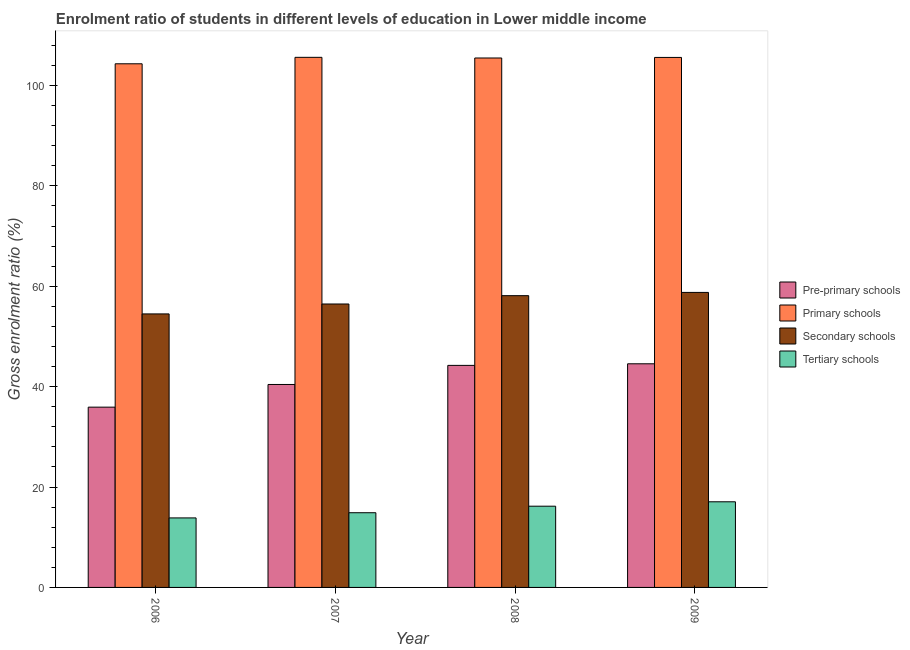How many bars are there on the 1st tick from the right?
Your response must be concise. 4. In how many cases, is the number of bars for a given year not equal to the number of legend labels?
Offer a terse response. 0. What is the gross enrolment ratio in pre-primary schools in 2007?
Your answer should be very brief. 40.44. Across all years, what is the maximum gross enrolment ratio in tertiary schools?
Your answer should be compact. 17.06. Across all years, what is the minimum gross enrolment ratio in secondary schools?
Your response must be concise. 54.5. What is the total gross enrolment ratio in tertiary schools in the graph?
Offer a terse response. 61.98. What is the difference between the gross enrolment ratio in tertiary schools in 2006 and that in 2009?
Your answer should be very brief. -3.21. What is the difference between the gross enrolment ratio in tertiary schools in 2008 and the gross enrolment ratio in primary schools in 2009?
Offer a very short reply. -0.88. What is the average gross enrolment ratio in pre-primary schools per year?
Keep it short and to the point. 41.29. In how many years, is the gross enrolment ratio in secondary schools greater than 64 %?
Your answer should be very brief. 0. What is the ratio of the gross enrolment ratio in primary schools in 2007 to that in 2008?
Offer a very short reply. 1. Is the gross enrolment ratio in secondary schools in 2007 less than that in 2008?
Offer a very short reply. Yes. What is the difference between the highest and the second highest gross enrolment ratio in primary schools?
Ensure brevity in your answer.  0.02. What is the difference between the highest and the lowest gross enrolment ratio in secondary schools?
Offer a terse response. 4.28. In how many years, is the gross enrolment ratio in secondary schools greater than the average gross enrolment ratio in secondary schools taken over all years?
Make the answer very short. 2. Is the sum of the gross enrolment ratio in pre-primary schools in 2007 and 2008 greater than the maximum gross enrolment ratio in tertiary schools across all years?
Offer a very short reply. Yes. Is it the case that in every year, the sum of the gross enrolment ratio in tertiary schools and gross enrolment ratio in secondary schools is greater than the sum of gross enrolment ratio in pre-primary schools and gross enrolment ratio in primary schools?
Your answer should be very brief. No. What does the 4th bar from the left in 2009 represents?
Provide a succinct answer. Tertiary schools. What does the 3rd bar from the right in 2008 represents?
Provide a short and direct response. Primary schools. Is it the case that in every year, the sum of the gross enrolment ratio in pre-primary schools and gross enrolment ratio in primary schools is greater than the gross enrolment ratio in secondary schools?
Make the answer very short. Yes. How many bars are there?
Ensure brevity in your answer.  16. What is the difference between two consecutive major ticks on the Y-axis?
Make the answer very short. 20. Does the graph contain any zero values?
Give a very brief answer. No. Does the graph contain grids?
Make the answer very short. No. Where does the legend appear in the graph?
Your response must be concise. Center right. How are the legend labels stacked?
Offer a very short reply. Vertical. What is the title of the graph?
Your response must be concise. Enrolment ratio of students in different levels of education in Lower middle income. Does "Subsidies and Transfers" appear as one of the legend labels in the graph?
Ensure brevity in your answer.  No. What is the label or title of the X-axis?
Give a very brief answer. Year. What is the Gross enrolment ratio (%) in Pre-primary schools in 2006?
Your answer should be compact. 35.92. What is the Gross enrolment ratio (%) of Primary schools in 2006?
Your answer should be compact. 104.33. What is the Gross enrolment ratio (%) in Secondary schools in 2006?
Your response must be concise. 54.5. What is the Gross enrolment ratio (%) in Tertiary schools in 2006?
Give a very brief answer. 13.85. What is the Gross enrolment ratio (%) of Pre-primary schools in 2007?
Provide a short and direct response. 40.44. What is the Gross enrolment ratio (%) of Primary schools in 2007?
Your answer should be compact. 105.62. What is the Gross enrolment ratio (%) in Secondary schools in 2007?
Provide a short and direct response. 56.47. What is the Gross enrolment ratio (%) in Tertiary schools in 2007?
Your answer should be compact. 14.88. What is the Gross enrolment ratio (%) of Pre-primary schools in 2008?
Offer a very short reply. 44.24. What is the Gross enrolment ratio (%) of Primary schools in 2008?
Keep it short and to the point. 105.49. What is the Gross enrolment ratio (%) of Secondary schools in 2008?
Make the answer very short. 58.13. What is the Gross enrolment ratio (%) of Tertiary schools in 2008?
Ensure brevity in your answer.  16.18. What is the Gross enrolment ratio (%) in Pre-primary schools in 2009?
Offer a terse response. 44.56. What is the Gross enrolment ratio (%) in Primary schools in 2009?
Offer a very short reply. 105.6. What is the Gross enrolment ratio (%) in Secondary schools in 2009?
Offer a terse response. 58.78. What is the Gross enrolment ratio (%) in Tertiary schools in 2009?
Offer a very short reply. 17.06. Across all years, what is the maximum Gross enrolment ratio (%) of Pre-primary schools?
Give a very brief answer. 44.56. Across all years, what is the maximum Gross enrolment ratio (%) in Primary schools?
Keep it short and to the point. 105.62. Across all years, what is the maximum Gross enrolment ratio (%) of Secondary schools?
Your answer should be compact. 58.78. Across all years, what is the maximum Gross enrolment ratio (%) of Tertiary schools?
Provide a succinct answer. 17.06. Across all years, what is the minimum Gross enrolment ratio (%) in Pre-primary schools?
Your response must be concise. 35.92. Across all years, what is the minimum Gross enrolment ratio (%) of Primary schools?
Your response must be concise. 104.33. Across all years, what is the minimum Gross enrolment ratio (%) of Secondary schools?
Give a very brief answer. 54.5. Across all years, what is the minimum Gross enrolment ratio (%) in Tertiary schools?
Keep it short and to the point. 13.85. What is the total Gross enrolment ratio (%) of Pre-primary schools in the graph?
Give a very brief answer. 165.16. What is the total Gross enrolment ratio (%) of Primary schools in the graph?
Your answer should be compact. 421.04. What is the total Gross enrolment ratio (%) in Secondary schools in the graph?
Provide a short and direct response. 227.88. What is the total Gross enrolment ratio (%) in Tertiary schools in the graph?
Your answer should be compact. 61.98. What is the difference between the Gross enrolment ratio (%) of Pre-primary schools in 2006 and that in 2007?
Offer a very short reply. -4.51. What is the difference between the Gross enrolment ratio (%) of Primary schools in 2006 and that in 2007?
Your response must be concise. -1.29. What is the difference between the Gross enrolment ratio (%) of Secondary schools in 2006 and that in 2007?
Offer a terse response. -1.98. What is the difference between the Gross enrolment ratio (%) of Tertiary schools in 2006 and that in 2007?
Offer a very short reply. -1.03. What is the difference between the Gross enrolment ratio (%) of Pre-primary schools in 2006 and that in 2008?
Provide a short and direct response. -8.32. What is the difference between the Gross enrolment ratio (%) of Primary schools in 2006 and that in 2008?
Provide a succinct answer. -1.15. What is the difference between the Gross enrolment ratio (%) in Secondary schools in 2006 and that in 2008?
Your answer should be compact. -3.63. What is the difference between the Gross enrolment ratio (%) in Tertiary schools in 2006 and that in 2008?
Offer a very short reply. -2.33. What is the difference between the Gross enrolment ratio (%) of Pre-primary schools in 2006 and that in 2009?
Your answer should be very brief. -8.64. What is the difference between the Gross enrolment ratio (%) of Primary schools in 2006 and that in 2009?
Your response must be concise. -1.27. What is the difference between the Gross enrolment ratio (%) of Secondary schools in 2006 and that in 2009?
Offer a very short reply. -4.28. What is the difference between the Gross enrolment ratio (%) of Tertiary schools in 2006 and that in 2009?
Your response must be concise. -3.21. What is the difference between the Gross enrolment ratio (%) in Pre-primary schools in 2007 and that in 2008?
Provide a short and direct response. -3.8. What is the difference between the Gross enrolment ratio (%) in Primary schools in 2007 and that in 2008?
Provide a succinct answer. 0.13. What is the difference between the Gross enrolment ratio (%) in Secondary schools in 2007 and that in 2008?
Provide a short and direct response. -1.66. What is the difference between the Gross enrolment ratio (%) in Tertiary schools in 2007 and that in 2008?
Keep it short and to the point. -1.3. What is the difference between the Gross enrolment ratio (%) of Pre-primary schools in 2007 and that in 2009?
Your answer should be very brief. -4.12. What is the difference between the Gross enrolment ratio (%) of Primary schools in 2007 and that in 2009?
Offer a terse response. 0.02. What is the difference between the Gross enrolment ratio (%) of Secondary schools in 2007 and that in 2009?
Ensure brevity in your answer.  -2.31. What is the difference between the Gross enrolment ratio (%) of Tertiary schools in 2007 and that in 2009?
Make the answer very short. -2.18. What is the difference between the Gross enrolment ratio (%) in Pre-primary schools in 2008 and that in 2009?
Provide a succinct answer. -0.32. What is the difference between the Gross enrolment ratio (%) in Primary schools in 2008 and that in 2009?
Your response must be concise. -0.11. What is the difference between the Gross enrolment ratio (%) of Secondary schools in 2008 and that in 2009?
Keep it short and to the point. -0.65. What is the difference between the Gross enrolment ratio (%) of Tertiary schools in 2008 and that in 2009?
Your answer should be compact. -0.88. What is the difference between the Gross enrolment ratio (%) in Pre-primary schools in 2006 and the Gross enrolment ratio (%) in Primary schools in 2007?
Keep it short and to the point. -69.7. What is the difference between the Gross enrolment ratio (%) in Pre-primary schools in 2006 and the Gross enrolment ratio (%) in Secondary schools in 2007?
Make the answer very short. -20.55. What is the difference between the Gross enrolment ratio (%) in Pre-primary schools in 2006 and the Gross enrolment ratio (%) in Tertiary schools in 2007?
Make the answer very short. 21.04. What is the difference between the Gross enrolment ratio (%) in Primary schools in 2006 and the Gross enrolment ratio (%) in Secondary schools in 2007?
Provide a short and direct response. 47.86. What is the difference between the Gross enrolment ratio (%) of Primary schools in 2006 and the Gross enrolment ratio (%) of Tertiary schools in 2007?
Offer a terse response. 89.45. What is the difference between the Gross enrolment ratio (%) of Secondary schools in 2006 and the Gross enrolment ratio (%) of Tertiary schools in 2007?
Give a very brief answer. 39.62. What is the difference between the Gross enrolment ratio (%) in Pre-primary schools in 2006 and the Gross enrolment ratio (%) in Primary schools in 2008?
Offer a terse response. -69.57. What is the difference between the Gross enrolment ratio (%) in Pre-primary schools in 2006 and the Gross enrolment ratio (%) in Secondary schools in 2008?
Provide a short and direct response. -22.21. What is the difference between the Gross enrolment ratio (%) in Pre-primary schools in 2006 and the Gross enrolment ratio (%) in Tertiary schools in 2008?
Keep it short and to the point. 19.74. What is the difference between the Gross enrolment ratio (%) in Primary schools in 2006 and the Gross enrolment ratio (%) in Secondary schools in 2008?
Give a very brief answer. 46.2. What is the difference between the Gross enrolment ratio (%) in Primary schools in 2006 and the Gross enrolment ratio (%) in Tertiary schools in 2008?
Provide a short and direct response. 88.15. What is the difference between the Gross enrolment ratio (%) of Secondary schools in 2006 and the Gross enrolment ratio (%) of Tertiary schools in 2008?
Offer a terse response. 38.31. What is the difference between the Gross enrolment ratio (%) of Pre-primary schools in 2006 and the Gross enrolment ratio (%) of Primary schools in 2009?
Your response must be concise. -69.68. What is the difference between the Gross enrolment ratio (%) of Pre-primary schools in 2006 and the Gross enrolment ratio (%) of Secondary schools in 2009?
Make the answer very short. -22.86. What is the difference between the Gross enrolment ratio (%) in Pre-primary schools in 2006 and the Gross enrolment ratio (%) in Tertiary schools in 2009?
Provide a short and direct response. 18.86. What is the difference between the Gross enrolment ratio (%) in Primary schools in 2006 and the Gross enrolment ratio (%) in Secondary schools in 2009?
Make the answer very short. 45.55. What is the difference between the Gross enrolment ratio (%) of Primary schools in 2006 and the Gross enrolment ratio (%) of Tertiary schools in 2009?
Offer a terse response. 87.27. What is the difference between the Gross enrolment ratio (%) of Secondary schools in 2006 and the Gross enrolment ratio (%) of Tertiary schools in 2009?
Offer a terse response. 37.43. What is the difference between the Gross enrolment ratio (%) in Pre-primary schools in 2007 and the Gross enrolment ratio (%) in Primary schools in 2008?
Your response must be concise. -65.05. What is the difference between the Gross enrolment ratio (%) in Pre-primary schools in 2007 and the Gross enrolment ratio (%) in Secondary schools in 2008?
Provide a succinct answer. -17.7. What is the difference between the Gross enrolment ratio (%) in Pre-primary schools in 2007 and the Gross enrolment ratio (%) in Tertiary schools in 2008?
Offer a terse response. 24.25. What is the difference between the Gross enrolment ratio (%) of Primary schools in 2007 and the Gross enrolment ratio (%) of Secondary schools in 2008?
Ensure brevity in your answer.  47.49. What is the difference between the Gross enrolment ratio (%) in Primary schools in 2007 and the Gross enrolment ratio (%) in Tertiary schools in 2008?
Offer a terse response. 89.44. What is the difference between the Gross enrolment ratio (%) in Secondary schools in 2007 and the Gross enrolment ratio (%) in Tertiary schools in 2008?
Offer a very short reply. 40.29. What is the difference between the Gross enrolment ratio (%) of Pre-primary schools in 2007 and the Gross enrolment ratio (%) of Primary schools in 2009?
Make the answer very short. -65.16. What is the difference between the Gross enrolment ratio (%) in Pre-primary schools in 2007 and the Gross enrolment ratio (%) in Secondary schools in 2009?
Your response must be concise. -18.34. What is the difference between the Gross enrolment ratio (%) of Pre-primary schools in 2007 and the Gross enrolment ratio (%) of Tertiary schools in 2009?
Provide a short and direct response. 23.37. What is the difference between the Gross enrolment ratio (%) of Primary schools in 2007 and the Gross enrolment ratio (%) of Secondary schools in 2009?
Provide a short and direct response. 46.84. What is the difference between the Gross enrolment ratio (%) of Primary schools in 2007 and the Gross enrolment ratio (%) of Tertiary schools in 2009?
Your response must be concise. 88.56. What is the difference between the Gross enrolment ratio (%) of Secondary schools in 2007 and the Gross enrolment ratio (%) of Tertiary schools in 2009?
Your answer should be very brief. 39.41. What is the difference between the Gross enrolment ratio (%) in Pre-primary schools in 2008 and the Gross enrolment ratio (%) in Primary schools in 2009?
Make the answer very short. -61.36. What is the difference between the Gross enrolment ratio (%) of Pre-primary schools in 2008 and the Gross enrolment ratio (%) of Secondary schools in 2009?
Your answer should be very brief. -14.54. What is the difference between the Gross enrolment ratio (%) in Pre-primary schools in 2008 and the Gross enrolment ratio (%) in Tertiary schools in 2009?
Give a very brief answer. 27.18. What is the difference between the Gross enrolment ratio (%) of Primary schools in 2008 and the Gross enrolment ratio (%) of Secondary schools in 2009?
Your answer should be compact. 46.71. What is the difference between the Gross enrolment ratio (%) in Primary schools in 2008 and the Gross enrolment ratio (%) in Tertiary schools in 2009?
Offer a very short reply. 88.42. What is the difference between the Gross enrolment ratio (%) in Secondary schools in 2008 and the Gross enrolment ratio (%) in Tertiary schools in 2009?
Keep it short and to the point. 41.07. What is the average Gross enrolment ratio (%) in Pre-primary schools per year?
Give a very brief answer. 41.29. What is the average Gross enrolment ratio (%) in Primary schools per year?
Offer a terse response. 105.26. What is the average Gross enrolment ratio (%) of Secondary schools per year?
Keep it short and to the point. 56.97. What is the average Gross enrolment ratio (%) of Tertiary schools per year?
Your answer should be compact. 15.49. In the year 2006, what is the difference between the Gross enrolment ratio (%) in Pre-primary schools and Gross enrolment ratio (%) in Primary schools?
Your response must be concise. -68.41. In the year 2006, what is the difference between the Gross enrolment ratio (%) in Pre-primary schools and Gross enrolment ratio (%) in Secondary schools?
Offer a very short reply. -18.58. In the year 2006, what is the difference between the Gross enrolment ratio (%) of Pre-primary schools and Gross enrolment ratio (%) of Tertiary schools?
Offer a very short reply. 22.07. In the year 2006, what is the difference between the Gross enrolment ratio (%) in Primary schools and Gross enrolment ratio (%) in Secondary schools?
Your answer should be compact. 49.83. In the year 2006, what is the difference between the Gross enrolment ratio (%) in Primary schools and Gross enrolment ratio (%) in Tertiary schools?
Your response must be concise. 90.48. In the year 2006, what is the difference between the Gross enrolment ratio (%) in Secondary schools and Gross enrolment ratio (%) in Tertiary schools?
Give a very brief answer. 40.65. In the year 2007, what is the difference between the Gross enrolment ratio (%) in Pre-primary schools and Gross enrolment ratio (%) in Primary schools?
Your response must be concise. -65.18. In the year 2007, what is the difference between the Gross enrolment ratio (%) in Pre-primary schools and Gross enrolment ratio (%) in Secondary schools?
Give a very brief answer. -16.04. In the year 2007, what is the difference between the Gross enrolment ratio (%) in Pre-primary schools and Gross enrolment ratio (%) in Tertiary schools?
Offer a terse response. 25.55. In the year 2007, what is the difference between the Gross enrolment ratio (%) in Primary schools and Gross enrolment ratio (%) in Secondary schools?
Offer a terse response. 49.15. In the year 2007, what is the difference between the Gross enrolment ratio (%) in Primary schools and Gross enrolment ratio (%) in Tertiary schools?
Offer a terse response. 90.74. In the year 2007, what is the difference between the Gross enrolment ratio (%) of Secondary schools and Gross enrolment ratio (%) of Tertiary schools?
Provide a succinct answer. 41.59. In the year 2008, what is the difference between the Gross enrolment ratio (%) in Pre-primary schools and Gross enrolment ratio (%) in Primary schools?
Your response must be concise. -61.25. In the year 2008, what is the difference between the Gross enrolment ratio (%) of Pre-primary schools and Gross enrolment ratio (%) of Secondary schools?
Your response must be concise. -13.89. In the year 2008, what is the difference between the Gross enrolment ratio (%) in Pre-primary schools and Gross enrolment ratio (%) in Tertiary schools?
Offer a very short reply. 28.06. In the year 2008, what is the difference between the Gross enrolment ratio (%) of Primary schools and Gross enrolment ratio (%) of Secondary schools?
Provide a short and direct response. 47.35. In the year 2008, what is the difference between the Gross enrolment ratio (%) in Primary schools and Gross enrolment ratio (%) in Tertiary schools?
Your answer should be compact. 89.3. In the year 2008, what is the difference between the Gross enrolment ratio (%) of Secondary schools and Gross enrolment ratio (%) of Tertiary schools?
Ensure brevity in your answer.  41.95. In the year 2009, what is the difference between the Gross enrolment ratio (%) of Pre-primary schools and Gross enrolment ratio (%) of Primary schools?
Your answer should be very brief. -61.04. In the year 2009, what is the difference between the Gross enrolment ratio (%) of Pre-primary schools and Gross enrolment ratio (%) of Secondary schools?
Provide a succinct answer. -14.22. In the year 2009, what is the difference between the Gross enrolment ratio (%) of Pre-primary schools and Gross enrolment ratio (%) of Tertiary schools?
Your response must be concise. 27.5. In the year 2009, what is the difference between the Gross enrolment ratio (%) of Primary schools and Gross enrolment ratio (%) of Secondary schools?
Your answer should be very brief. 46.82. In the year 2009, what is the difference between the Gross enrolment ratio (%) in Primary schools and Gross enrolment ratio (%) in Tertiary schools?
Offer a terse response. 88.54. In the year 2009, what is the difference between the Gross enrolment ratio (%) in Secondary schools and Gross enrolment ratio (%) in Tertiary schools?
Provide a succinct answer. 41.72. What is the ratio of the Gross enrolment ratio (%) in Pre-primary schools in 2006 to that in 2007?
Keep it short and to the point. 0.89. What is the ratio of the Gross enrolment ratio (%) in Tertiary schools in 2006 to that in 2007?
Provide a short and direct response. 0.93. What is the ratio of the Gross enrolment ratio (%) of Pre-primary schools in 2006 to that in 2008?
Offer a very short reply. 0.81. What is the ratio of the Gross enrolment ratio (%) in Primary schools in 2006 to that in 2008?
Provide a succinct answer. 0.99. What is the ratio of the Gross enrolment ratio (%) of Tertiary schools in 2006 to that in 2008?
Offer a terse response. 0.86. What is the ratio of the Gross enrolment ratio (%) in Pre-primary schools in 2006 to that in 2009?
Your answer should be compact. 0.81. What is the ratio of the Gross enrolment ratio (%) in Secondary schools in 2006 to that in 2009?
Your response must be concise. 0.93. What is the ratio of the Gross enrolment ratio (%) in Tertiary schools in 2006 to that in 2009?
Provide a succinct answer. 0.81. What is the ratio of the Gross enrolment ratio (%) in Pre-primary schools in 2007 to that in 2008?
Ensure brevity in your answer.  0.91. What is the ratio of the Gross enrolment ratio (%) of Primary schools in 2007 to that in 2008?
Your answer should be compact. 1. What is the ratio of the Gross enrolment ratio (%) of Secondary schools in 2007 to that in 2008?
Provide a succinct answer. 0.97. What is the ratio of the Gross enrolment ratio (%) in Tertiary schools in 2007 to that in 2008?
Give a very brief answer. 0.92. What is the ratio of the Gross enrolment ratio (%) in Pre-primary schools in 2007 to that in 2009?
Give a very brief answer. 0.91. What is the ratio of the Gross enrolment ratio (%) of Secondary schools in 2007 to that in 2009?
Offer a very short reply. 0.96. What is the ratio of the Gross enrolment ratio (%) in Tertiary schools in 2007 to that in 2009?
Offer a terse response. 0.87. What is the ratio of the Gross enrolment ratio (%) of Pre-primary schools in 2008 to that in 2009?
Offer a terse response. 0.99. What is the ratio of the Gross enrolment ratio (%) in Tertiary schools in 2008 to that in 2009?
Give a very brief answer. 0.95. What is the difference between the highest and the second highest Gross enrolment ratio (%) in Pre-primary schools?
Your response must be concise. 0.32. What is the difference between the highest and the second highest Gross enrolment ratio (%) in Primary schools?
Provide a short and direct response. 0.02. What is the difference between the highest and the second highest Gross enrolment ratio (%) in Secondary schools?
Your answer should be very brief. 0.65. What is the difference between the highest and the second highest Gross enrolment ratio (%) in Tertiary schools?
Keep it short and to the point. 0.88. What is the difference between the highest and the lowest Gross enrolment ratio (%) in Pre-primary schools?
Ensure brevity in your answer.  8.64. What is the difference between the highest and the lowest Gross enrolment ratio (%) in Primary schools?
Your answer should be very brief. 1.29. What is the difference between the highest and the lowest Gross enrolment ratio (%) in Secondary schools?
Make the answer very short. 4.28. What is the difference between the highest and the lowest Gross enrolment ratio (%) of Tertiary schools?
Your answer should be compact. 3.21. 